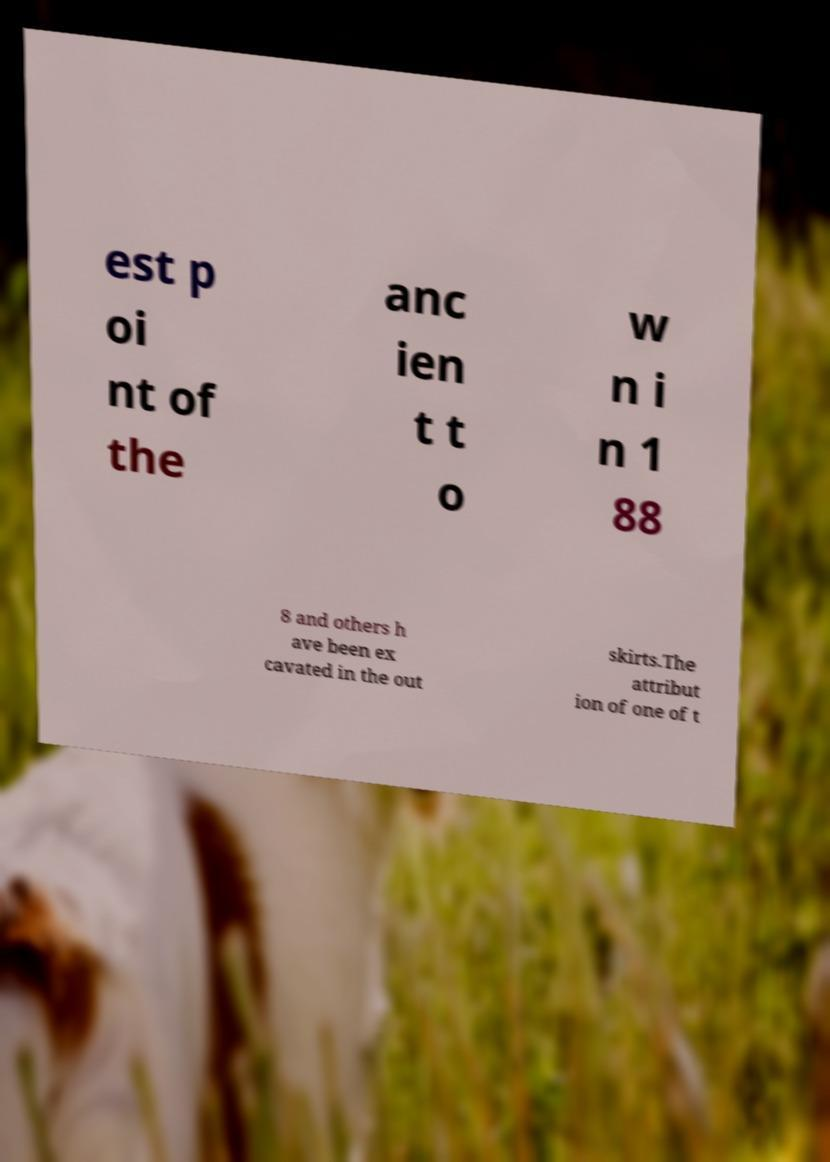Can you accurately transcribe the text from the provided image for me? est p oi nt of the anc ien t t o w n i n 1 88 8 and others h ave been ex cavated in the out skirts.The attribut ion of one of t 